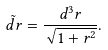<formula> <loc_0><loc_0><loc_500><loc_500>\tilde { d r } = { \frac { d ^ { 3 } r } { \sqrt { 1 + r ^ { 2 } } } } .</formula> 